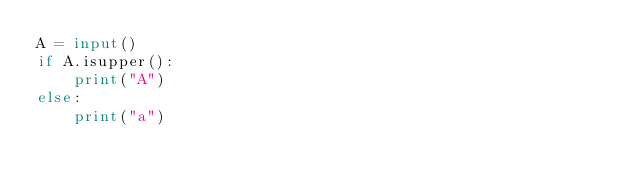Convert code to text. <code><loc_0><loc_0><loc_500><loc_500><_Python_>A = input()
if A.isupper():
    print("A")
else:
    print("a")</code> 